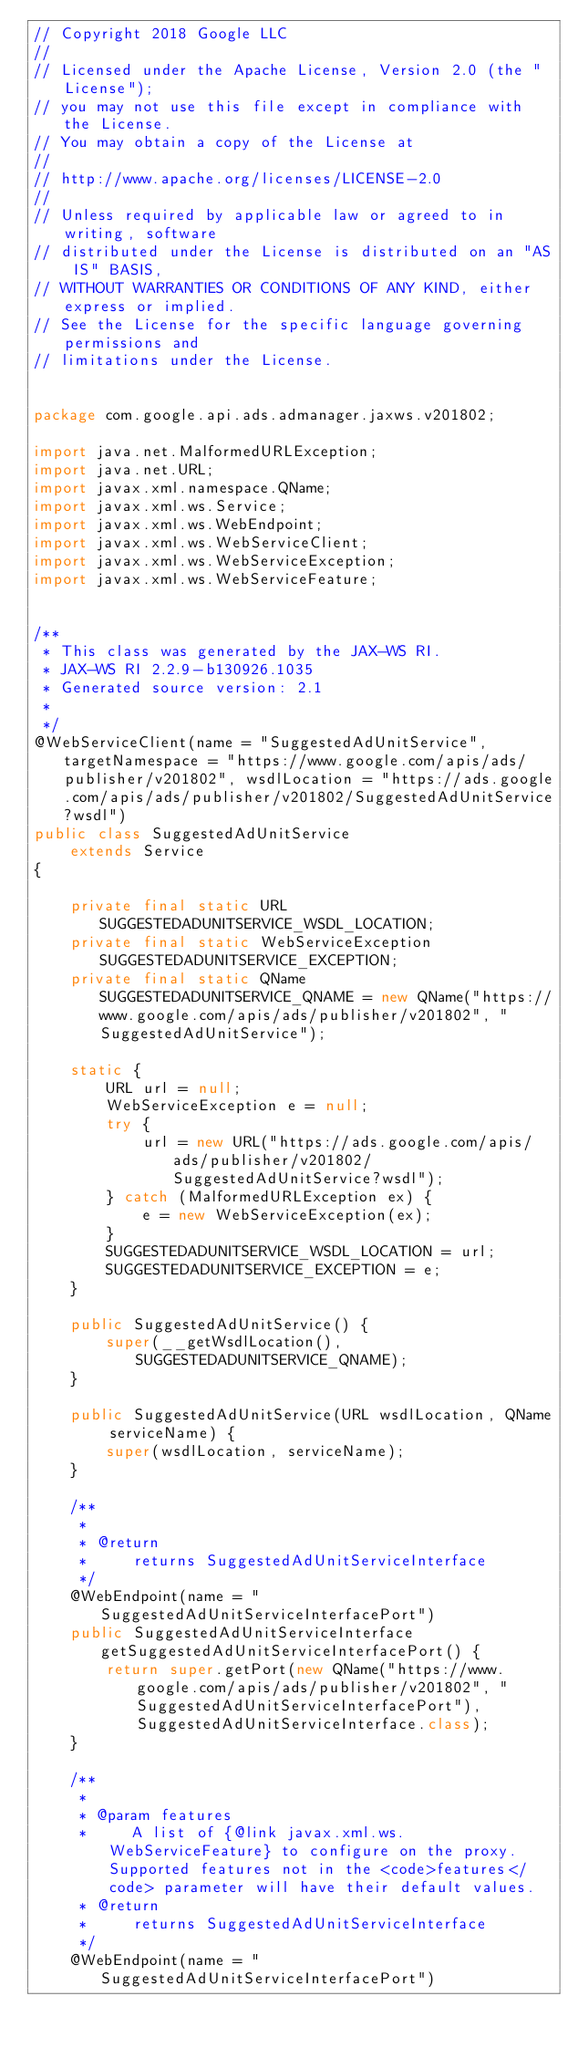Convert code to text. <code><loc_0><loc_0><loc_500><loc_500><_Java_>// Copyright 2018 Google LLC
//
// Licensed under the Apache License, Version 2.0 (the "License");
// you may not use this file except in compliance with the License.
// You may obtain a copy of the License at
//
// http://www.apache.org/licenses/LICENSE-2.0
//
// Unless required by applicable law or agreed to in writing, software
// distributed under the License is distributed on an "AS IS" BASIS,
// WITHOUT WARRANTIES OR CONDITIONS OF ANY KIND, either express or implied.
// See the License for the specific language governing permissions and
// limitations under the License.


package com.google.api.ads.admanager.jaxws.v201802;

import java.net.MalformedURLException;
import java.net.URL;
import javax.xml.namespace.QName;
import javax.xml.ws.Service;
import javax.xml.ws.WebEndpoint;
import javax.xml.ws.WebServiceClient;
import javax.xml.ws.WebServiceException;
import javax.xml.ws.WebServiceFeature;


/**
 * This class was generated by the JAX-WS RI.
 * JAX-WS RI 2.2.9-b130926.1035
 * Generated source version: 2.1
 * 
 */
@WebServiceClient(name = "SuggestedAdUnitService", targetNamespace = "https://www.google.com/apis/ads/publisher/v201802", wsdlLocation = "https://ads.google.com/apis/ads/publisher/v201802/SuggestedAdUnitService?wsdl")
public class SuggestedAdUnitService
    extends Service
{

    private final static URL SUGGESTEDADUNITSERVICE_WSDL_LOCATION;
    private final static WebServiceException SUGGESTEDADUNITSERVICE_EXCEPTION;
    private final static QName SUGGESTEDADUNITSERVICE_QNAME = new QName("https://www.google.com/apis/ads/publisher/v201802", "SuggestedAdUnitService");

    static {
        URL url = null;
        WebServiceException e = null;
        try {
            url = new URL("https://ads.google.com/apis/ads/publisher/v201802/SuggestedAdUnitService?wsdl");
        } catch (MalformedURLException ex) {
            e = new WebServiceException(ex);
        }
        SUGGESTEDADUNITSERVICE_WSDL_LOCATION = url;
        SUGGESTEDADUNITSERVICE_EXCEPTION = e;
    }

    public SuggestedAdUnitService() {
        super(__getWsdlLocation(), SUGGESTEDADUNITSERVICE_QNAME);
    }

    public SuggestedAdUnitService(URL wsdlLocation, QName serviceName) {
        super(wsdlLocation, serviceName);
    }

    /**
     * 
     * @return
     *     returns SuggestedAdUnitServiceInterface
     */
    @WebEndpoint(name = "SuggestedAdUnitServiceInterfacePort")
    public SuggestedAdUnitServiceInterface getSuggestedAdUnitServiceInterfacePort() {
        return super.getPort(new QName("https://www.google.com/apis/ads/publisher/v201802", "SuggestedAdUnitServiceInterfacePort"), SuggestedAdUnitServiceInterface.class);
    }

    /**
     * 
     * @param features
     *     A list of {@link javax.xml.ws.WebServiceFeature} to configure on the proxy.  Supported features not in the <code>features</code> parameter will have their default values.
     * @return
     *     returns SuggestedAdUnitServiceInterface
     */
    @WebEndpoint(name = "SuggestedAdUnitServiceInterfacePort")</code> 